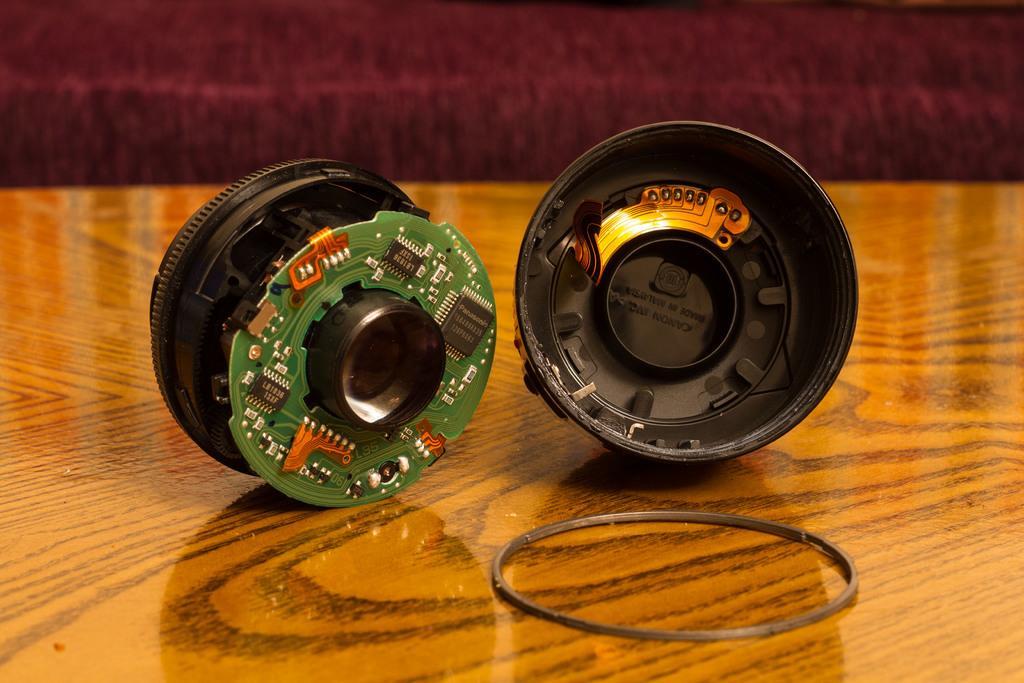Can you describe this image briefly? In this picture we can see an electronic equipment here, there is a circuit board here, we can see a rubber band here, at the bottom there is a wooden surface. 